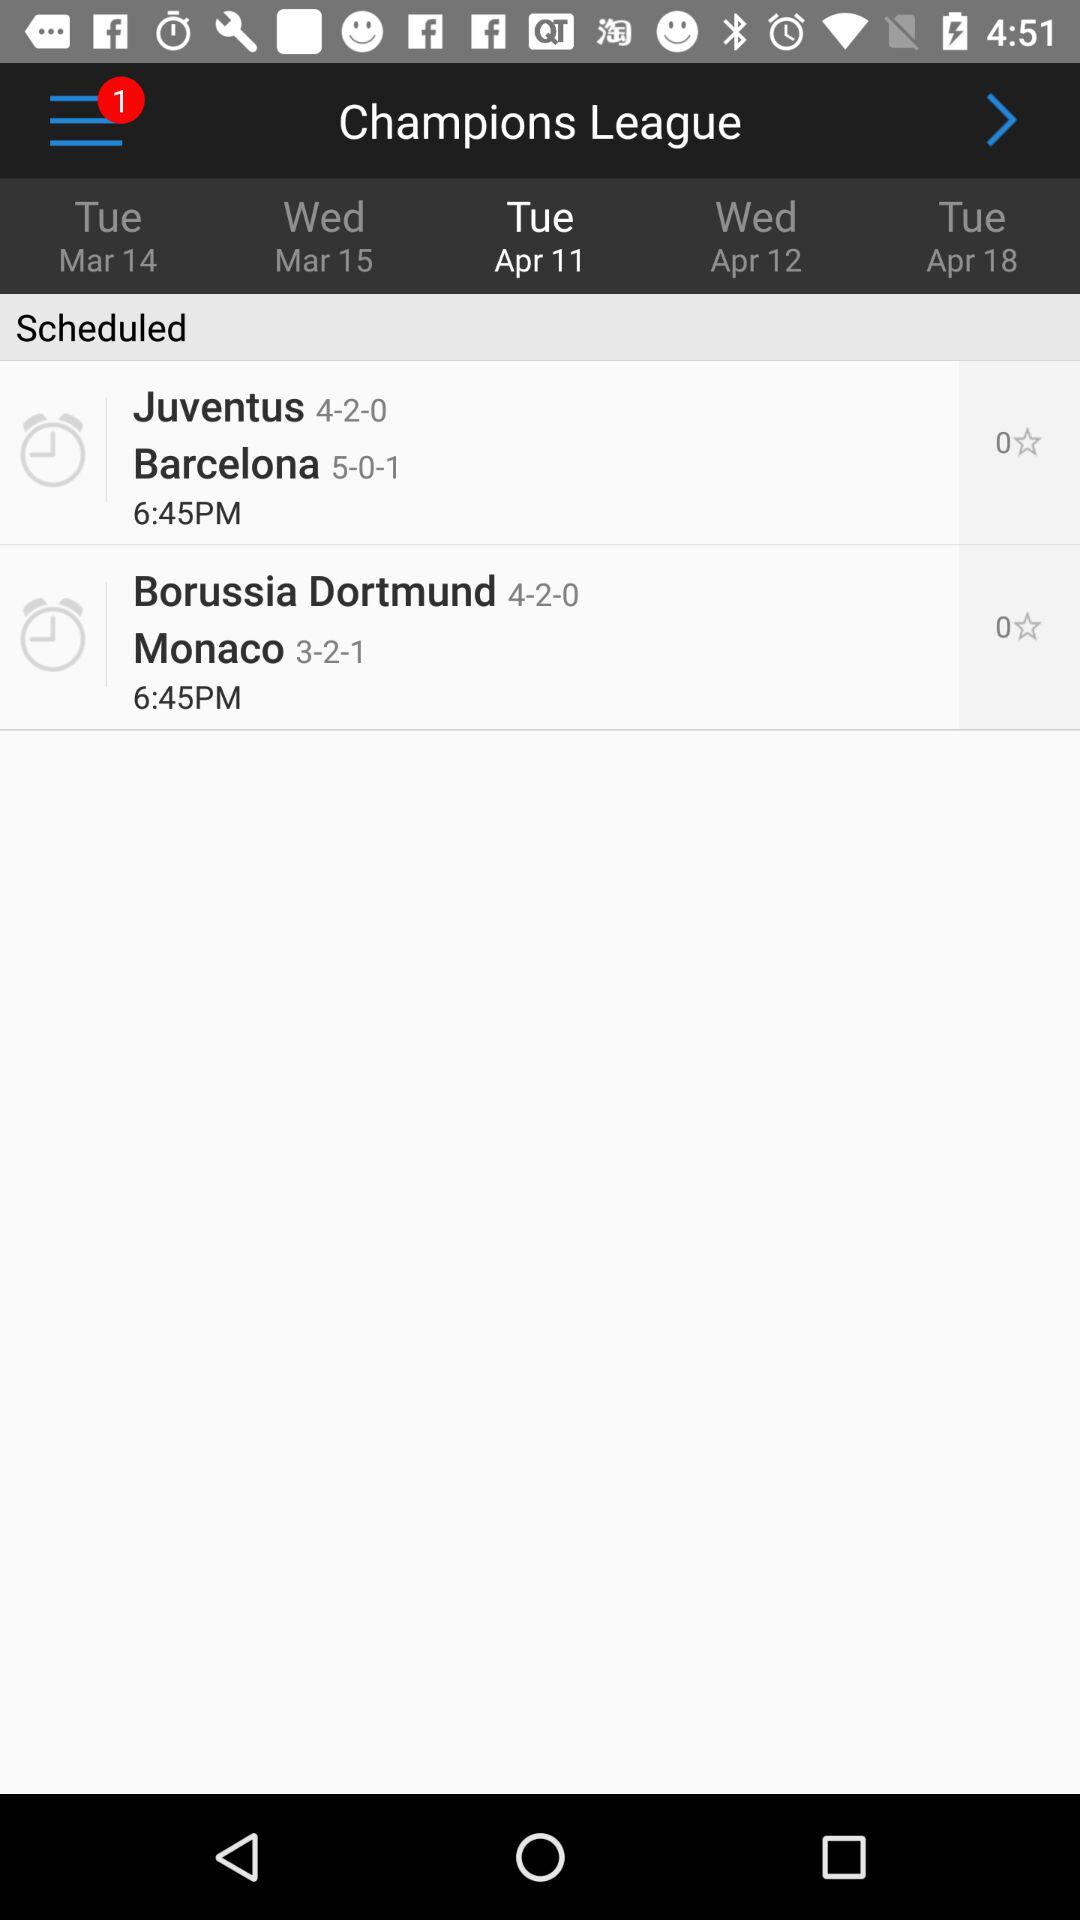How many stars did the Borussia Dortmund vs Monaco match get?
When the provided information is insufficient, respond with <no answer>. <no answer> 